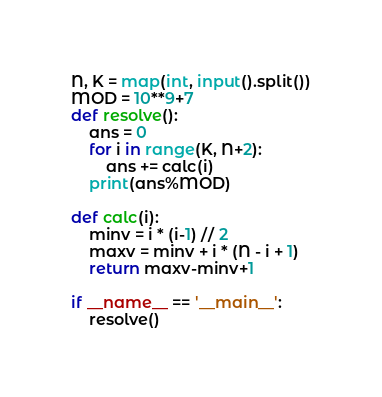Convert code to text. <code><loc_0><loc_0><loc_500><loc_500><_Python_>N, K = map(int, input().split())
MOD = 10**9+7
def resolve():
    ans = 0
    for i in range(K, N+2):
        ans += calc(i)
    print(ans%MOD)

def calc(i):
    minv = i * (i-1) // 2
    maxv = minv + i * (N - i + 1)
    return maxv-minv+1

if __name__ == '__main__':
    resolve()</code> 